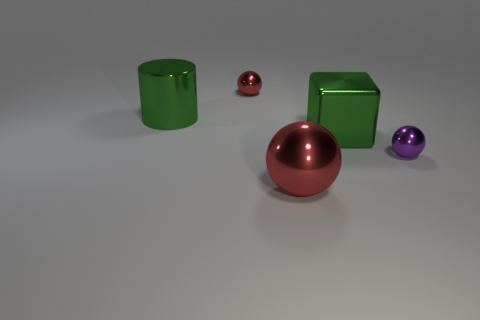Is the size of the cylinder the same as the red shiny ball that is behind the purple metal sphere?
Ensure brevity in your answer.  No. What is the tiny ball that is on the right side of the shiny object that is behind the green cylinder made of?
Your answer should be compact. Metal. There is a shiny thing that is in front of the small object in front of the large green object left of the big sphere; what is its size?
Provide a succinct answer. Large. There is a small red object; is it the same shape as the green object that is on the right side of the green cylinder?
Provide a succinct answer. No. What number of shiny things are purple objects or green cylinders?
Keep it short and to the point. 2. Is the number of large shiny cylinders behind the green shiny cylinder less than the number of small metal spheres in front of the big red shiny object?
Your response must be concise. No. There is a red metal thing in front of the small metallic object behind the small purple object; are there any metal spheres on the left side of it?
Ensure brevity in your answer.  Yes. There is another sphere that is the same color as the large metallic sphere; what is its material?
Offer a very short reply. Metal. There is a large thing in front of the big metallic cube; is its shape the same as the red object that is behind the big red object?
Offer a very short reply. Yes. There is a green object that is the same size as the green metal block; what is it made of?
Your answer should be compact. Metal. 